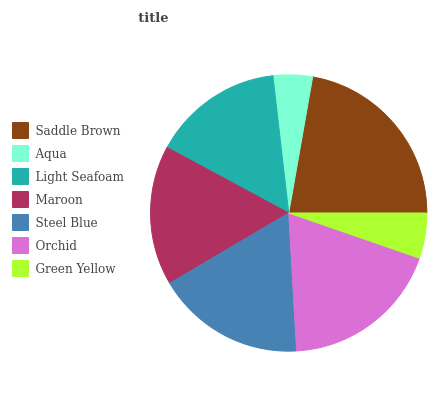Is Aqua the minimum?
Answer yes or no. Yes. Is Saddle Brown the maximum?
Answer yes or no. Yes. Is Light Seafoam the minimum?
Answer yes or no. No. Is Light Seafoam the maximum?
Answer yes or no. No. Is Light Seafoam greater than Aqua?
Answer yes or no. Yes. Is Aqua less than Light Seafoam?
Answer yes or no. Yes. Is Aqua greater than Light Seafoam?
Answer yes or no. No. Is Light Seafoam less than Aqua?
Answer yes or no. No. Is Maroon the high median?
Answer yes or no. Yes. Is Maroon the low median?
Answer yes or no. Yes. Is Aqua the high median?
Answer yes or no. No. Is Orchid the low median?
Answer yes or no. No. 